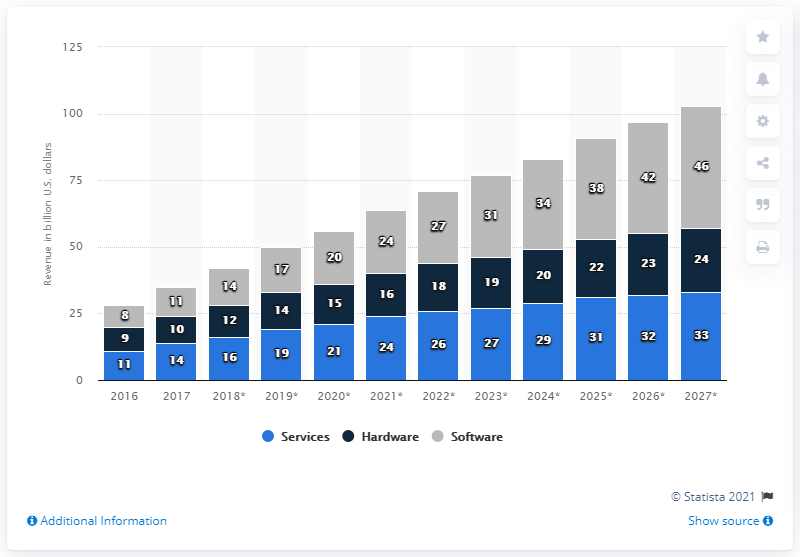List a handful of essential elements in this visual. The big data software market was estimated to be worth approximately 14 billion dollars in 2018. The global big data software market is estimated to be worth approximately 42 dollars. 